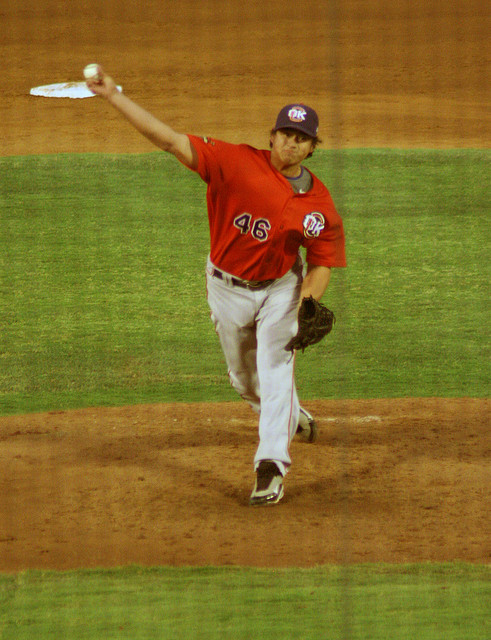Please transcribe the text in this image. OK OK 4 6 